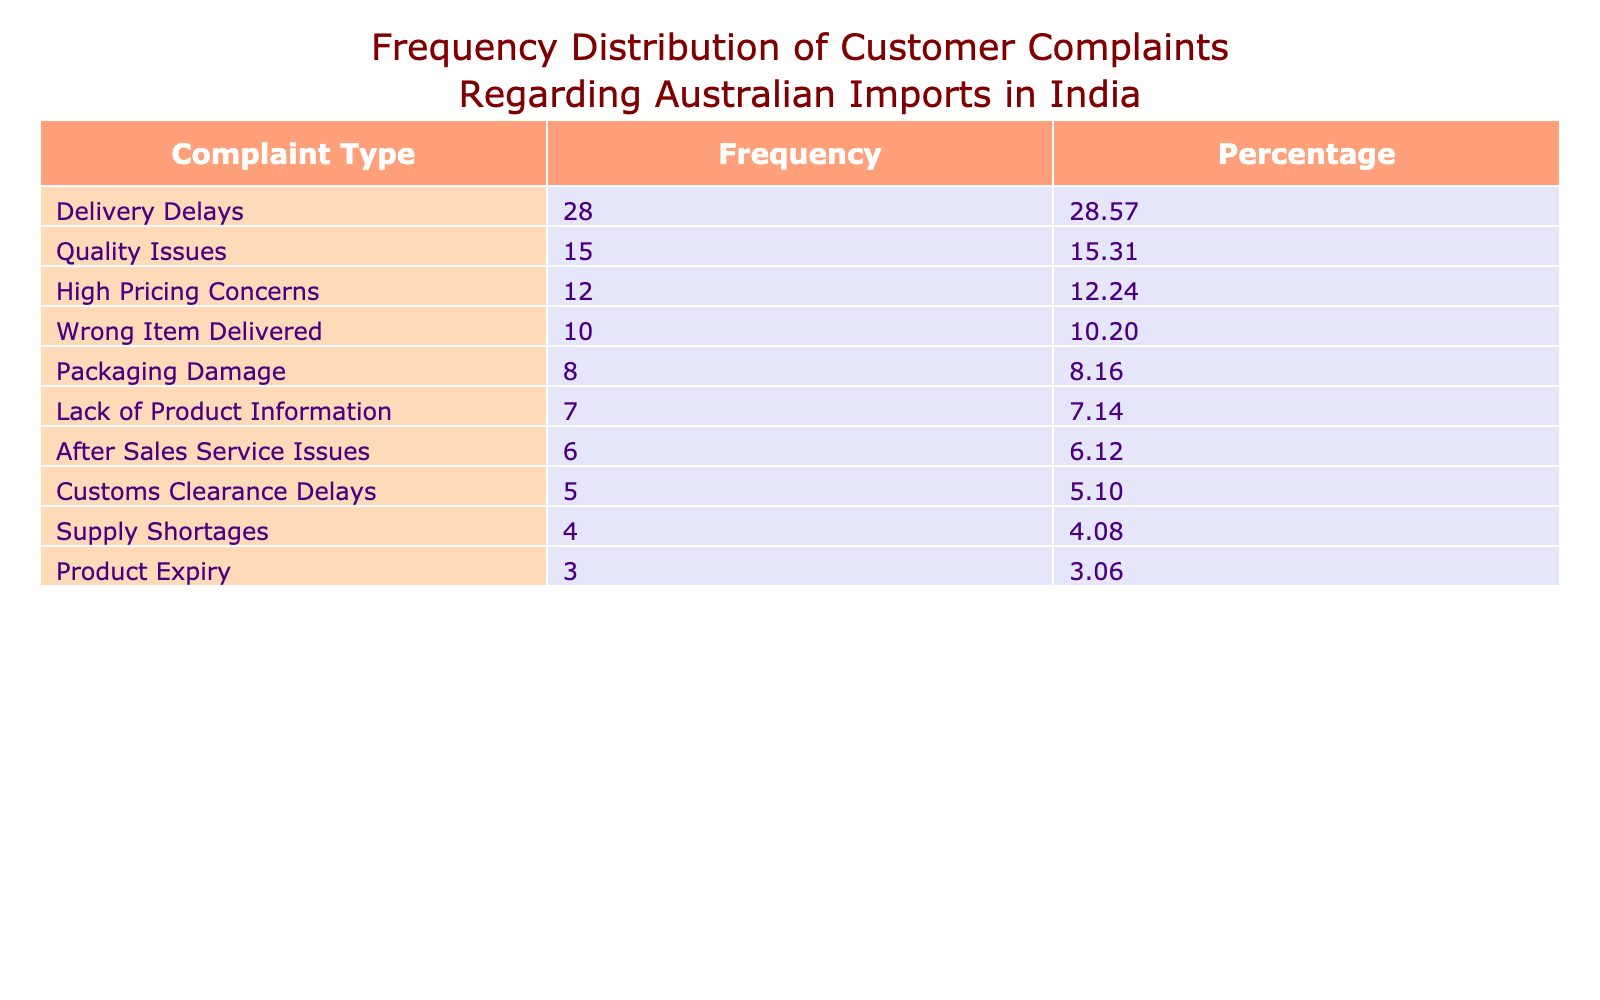What is the frequency of delivery delays reported by customers? The table shows that the count for delivery delays is listed under the 'Count' column corresponding to 'Delivery Delays'. This count is 28.
Answer: 28 What percentage of total complaints does the category of packaging damage represent? To find the percentage of packaging damage, first identify the count for packaging damage, which is 8. The total number of complaints is the sum of all counts: 28 + 15 + 10 + 8 + 12 + 5 + 3 + 4 + 7 + 6 = 93. Then, calculate the percentage: (8 / 93) * 100 ≈ 8.60%.
Answer: Approximately 8.60% Which complaint type has the highest frequency? The table lists the 'Frequency' column, and the highest value is for delivery delays, which is 28.
Answer: Delivery Delays Are there fewer complaints regarding product expiry compared to customs clearance delays? The count for product expiry is 3, while customs clearance delays have a count of 5. Since 3 is less than 5, it confirms that there are indeed fewer complaints regarding product expiry.
Answer: Yes What is the total frequency of complaints related to quality issues and wrong item delivery? First, find the counts for quality issues (15) and wrong item delivered (10). Then sum these two counts: 15 + 10 = 25.
Answer: 25 Which two complaint types combined account for more than 50% of total complaints? First, we must calculate the total complaints: 93. We are looking for combinations of complaint types whose frequencies exceed half of the total (i.e., 46.5). Delivery delays (28) + quality issues (15) = 43, which is not enough. Delivery delays (28) + high pricing concerns (12) = 40, still not enough. The combination of delivery delays (28) + packaging damage (8) + quality issues (15) = 51, exceeds 50%.
Answer: Delivery Delays, Quality Issues, Packaging Damage How many types of complaints have a frequency of less than 10? From the table, the complaint types with counts below 10 are packaging damage (8), customs clearance delays (5), product expiry (3), supply shortages (4), and after-sales service issues (6). There are 5 complaint types in total that meet this criterion.
Answer: 5 What percentage of complaints are concerned with high pricing? The count for high pricing concerns is 12. The total complaints are 93. The percentage of high pricing concerns is calculated as (12 / 93) * 100 ≈ 12.90%.
Answer: Approximately 12.90% Is the number of complaints related to after-sales service more than those regarding customs clearance delays? The number of complaints related to after-sales service issues is 6, while customs clearance delays have a count of 5. Since 6 is greater than 5, the statement is true.
Answer: Yes 